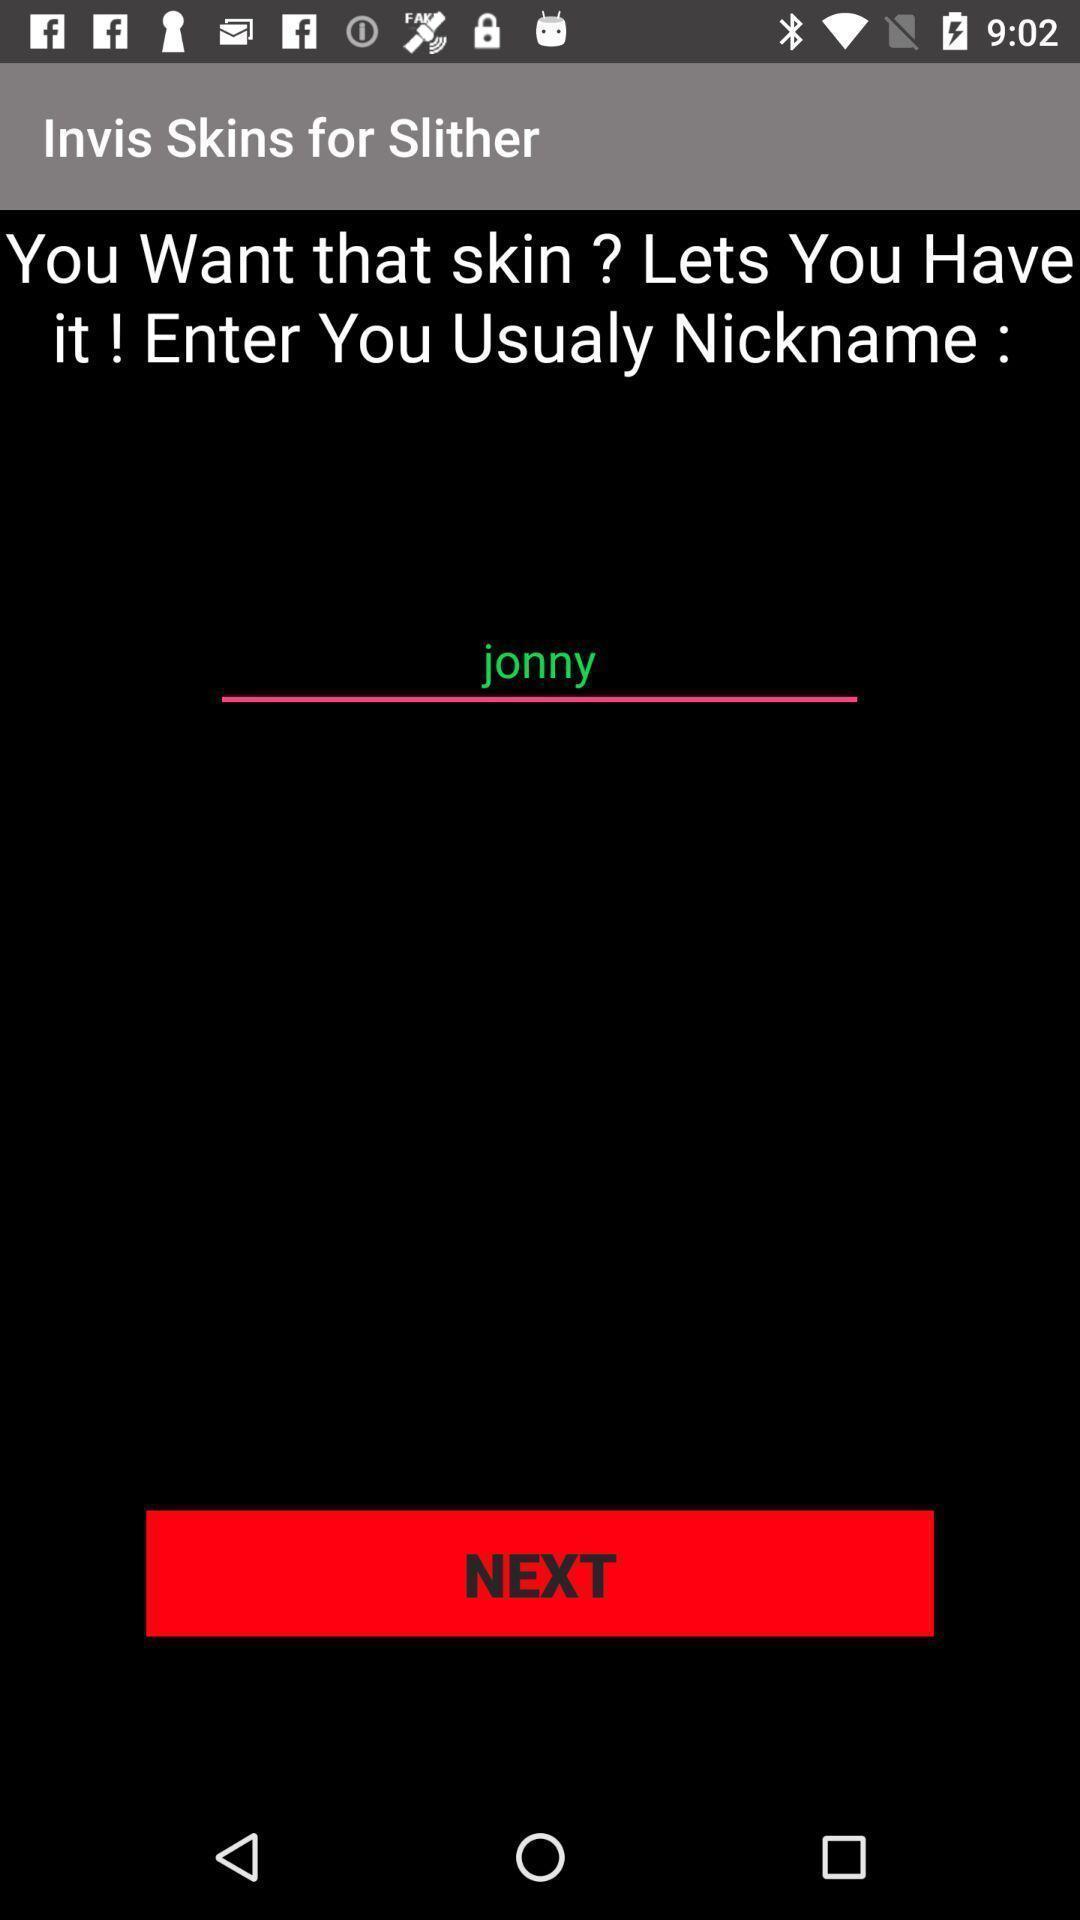Provide a textual representation of this image. Page shows to enter nickname. 